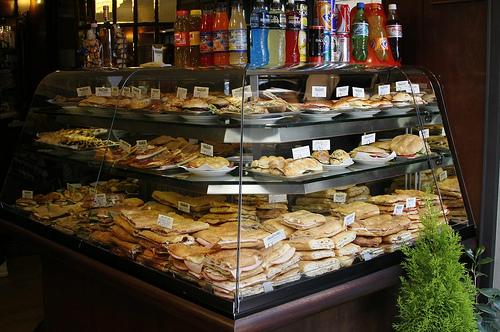How many shelves are there?
Write a very short answer. 3. Are there drinks for sale?
Be succinct. Yes. What kind of food is being sold?
Give a very brief answer. Sandwiches. What is the green thing?
Keep it brief. Plant. 